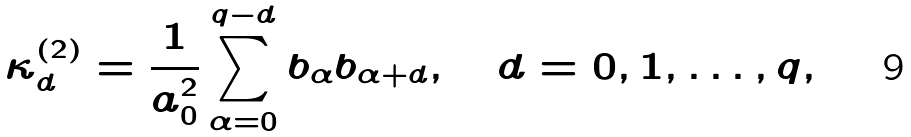Convert formula to latex. <formula><loc_0><loc_0><loc_500><loc_500>\kappa ^ { ( 2 ) } _ { d } = \frac { 1 } { a _ { 0 } ^ { 2 } } \sum _ { \alpha = 0 } ^ { q - d } b _ { \alpha } b _ { \alpha + d } , \quad d = 0 , 1 , \dots , q ,</formula> 